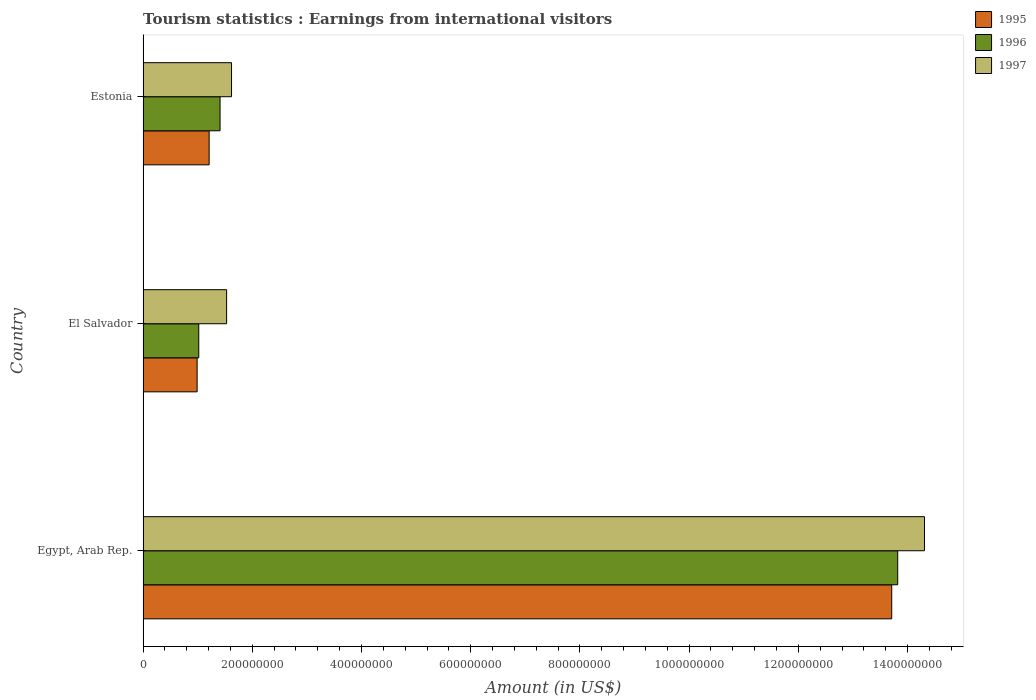How many groups of bars are there?
Ensure brevity in your answer.  3. Are the number of bars on each tick of the Y-axis equal?
Make the answer very short. Yes. What is the label of the 3rd group of bars from the top?
Keep it short and to the point. Egypt, Arab Rep. What is the earnings from international visitors in 1997 in El Salvador?
Offer a terse response. 1.53e+08. Across all countries, what is the maximum earnings from international visitors in 1995?
Your answer should be compact. 1.37e+09. Across all countries, what is the minimum earnings from international visitors in 1997?
Make the answer very short. 1.53e+08. In which country was the earnings from international visitors in 1997 maximum?
Offer a terse response. Egypt, Arab Rep. In which country was the earnings from international visitors in 1996 minimum?
Your response must be concise. El Salvador. What is the total earnings from international visitors in 1997 in the graph?
Make the answer very short. 1.75e+09. What is the difference between the earnings from international visitors in 1997 in Egypt, Arab Rep. and that in El Salvador?
Ensure brevity in your answer.  1.28e+09. What is the difference between the earnings from international visitors in 1996 in Estonia and the earnings from international visitors in 1995 in Egypt, Arab Rep.?
Provide a succinct answer. -1.23e+09. What is the average earnings from international visitors in 1997 per country?
Make the answer very short. 5.82e+08. What is the difference between the earnings from international visitors in 1997 and earnings from international visitors in 1996 in El Salvador?
Provide a short and direct response. 5.10e+07. In how many countries, is the earnings from international visitors in 1995 greater than 1360000000 US$?
Keep it short and to the point. 1. What is the ratio of the earnings from international visitors in 1996 in Egypt, Arab Rep. to that in El Salvador?
Give a very brief answer. 13.55. Is the earnings from international visitors in 1997 in Egypt, Arab Rep. less than that in El Salvador?
Keep it short and to the point. No. What is the difference between the highest and the second highest earnings from international visitors in 1995?
Offer a very short reply. 1.25e+09. What is the difference between the highest and the lowest earnings from international visitors in 1997?
Ensure brevity in your answer.  1.28e+09. In how many countries, is the earnings from international visitors in 1996 greater than the average earnings from international visitors in 1996 taken over all countries?
Keep it short and to the point. 1. What does the 1st bar from the top in Estonia represents?
Offer a terse response. 1997. How many bars are there?
Ensure brevity in your answer.  9. Are all the bars in the graph horizontal?
Ensure brevity in your answer.  Yes. Does the graph contain grids?
Your response must be concise. No. What is the title of the graph?
Provide a short and direct response. Tourism statistics : Earnings from international visitors. What is the label or title of the Y-axis?
Ensure brevity in your answer.  Country. What is the Amount (in US$) of 1995 in Egypt, Arab Rep.?
Your response must be concise. 1.37e+09. What is the Amount (in US$) of 1996 in Egypt, Arab Rep.?
Your response must be concise. 1.38e+09. What is the Amount (in US$) of 1997 in Egypt, Arab Rep.?
Offer a very short reply. 1.43e+09. What is the Amount (in US$) in 1995 in El Salvador?
Provide a short and direct response. 9.90e+07. What is the Amount (in US$) of 1996 in El Salvador?
Make the answer very short. 1.02e+08. What is the Amount (in US$) of 1997 in El Salvador?
Offer a terse response. 1.53e+08. What is the Amount (in US$) in 1995 in Estonia?
Provide a succinct answer. 1.21e+08. What is the Amount (in US$) in 1996 in Estonia?
Your answer should be compact. 1.41e+08. What is the Amount (in US$) of 1997 in Estonia?
Your answer should be very brief. 1.62e+08. Across all countries, what is the maximum Amount (in US$) in 1995?
Give a very brief answer. 1.37e+09. Across all countries, what is the maximum Amount (in US$) in 1996?
Provide a short and direct response. 1.38e+09. Across all countries, what is the maximum Amount (in US$) in 1997?
Ensure brevity in your answer.  1.43e+09. Across all countries, what is the minimum Amount (in US$) in 1995?
Your answer should be compact. 9.90e+07. Across all countries, what is the minimum Amount (in US$) of 1996?
Offer a terse response. 1.02e+08. Across all countries, what is the minimum Amount (in US$) of 1997?
Provide a short and direct response. 1.53e+08. What is the total Amount (in US$) in 1995 in the graph?
Your answer should be very brief. 1.59e+09. What is the total Amount (in US$) in 1996 in the graph?
Provide a succinct answer. 1.62e+09. What is the total Amount (in US$) in 1997 in the graph?
Your response must be concise. 1.75e+09. What is the difference between the Amount (in US$) of 1995 in Egypt, Arab Rep. and that in El Salvador?
Your answer should be very brief. 1.27e+09. What is the difference between the Amount (in US$) of 1996 in Egypt, Arab Rep. and that in El Salvador?
Provide a short and direct response. 1.28e+09. What is the difference between the Amount (in US$) of 1997 in Egypt, Arab Rep. and that in El Salvador?
Make the answer very short. 1.28e+09. What is the difference between the Amount (in US$) in 1995 in Egypt, Arab Rep. and that in Estonia?
Ensure brevity in your answer.  1.25e+09. What is the difference between the Amount (in US$) in 1996 in Egypt, Arab Rep. and that in Estonia?
Offer a very short reply. 1.24e+09. What is the difference between the Amount (in US$) of 1997 in Egypt, Arab Rep. and that in Estonia?
Make the answer very short. 1.27e+09. What is the difference between the Amount (in US$) of 1995 in El Salvador and that in Estonia?
Provide a succinct answer. -2.20e+07. What is the difference between the Amount (in US$) of 1996 in El Salvador and that in Estonia?
Provide a short and direct response. -3.90e+07. What is the difference between the Amount (in US$) of 1997 in El Salvador and that in Estonia?
Your response must be concise. -9.00e+06. What is the difference between the Amount (in US$) in 1995 in Egypt, Arab Rep. and the Amount (in US$) in 1996 in El Salvador?
Make the answer very short. 1.27e+09. What is the difference between the Amount (in US$) in 1995 in Egypt, Arab Rep. and the Amount (in US$) in 1997 in El Salvador?
Offer a terse response. 1.22e+09. What is the difference between the Amount (in US$) of 1996 in Egypt, Arab Rep. and the Amount (in US$) of 1997 in El Salvador?
Give a very brief answer. 1.23e+09. What is the difference between the Amount (in US$) in 1995 in Egypt, Arab Rep. and the Amount (in US$) in 1996 in Estonia?
Keep it short and to the point. 1.23e+09. What is the difference between the Amount (in US$) of 1995 in Egypt, Arab Rep. and the Amount (in US$) of 1997 in Estonia?
Your response must be concise. 1.21e+09. What is the difference between the Amount (in US$) of 1996 in Egypt, Arab Rep. and the Amount (in US$) of 1997 in Estonia?
Your answer should be very brief. 1.22e+09. What is the difference between the Amount (in US$) of 1995 in El Salvador and the Amount (in US$) of 1996 in Estonia?
Your answer should be compact. -4.20e+07. What is the difference between the Amount (in US$) of 1995 in El Salvador and the Amount (in US$) of 1997 in Estonia?
Offer a very short reply. -6.30e+07. What is the difference between the Amount (in US$) of 1996 in El Salvador and the Amount (in US$) of 1997 in Estonia?
Your response must be concise. -6.00e+07. What is the average Amount (in US$) of 1995 per country?
Your answer should be compact. 5.30e+08. What is the average Amount (in US$) in 1996 per country?
Offer a terse response. 5.42e+08. What is the average Amount (in US$) of 1997 per country?
Give a very brief answer. 5.82e+08. What is the difference between the Amount (in US$) in 1995 and Amount (in US$) in 1996 in Egypt, Arab Rep.?
Ensure brevity in your answer.  -1.10e+07. What is the difference between the Amount (in US$) of 1995 and Amount (in US$) of 1997 in Egypt, Arab Rep.?
Ensure brevity in your answer.  -6.00e+07. What is the difference between the Amount (in US$) in 1996 and Amount (in US$) in 1997 in Egypt, Arab Rep.?
Offer a very short reply. -4.90e+07. What is the difference between the Amount (in US$) of 1995 and Amount (in US$) of 1997 in El Salvador?
Give a very brief answer. -5.40e+07. What is the difference between the Amount (in US$) of 1996 and Amount (in US$) of 1997 in El Salvador?
Your response must be concise. -5.10e+07. What is the difference between the Amount (in US$) in 1995 and Amount (in US$) in 1996 in Estonia?
Give a very brief answer. -2.00e+07. What is the difference between the Amount (in US$) in 1995 and Amount (in US$) in 1997 in Estonia?
Your response must be concise. -4.10e+07. What is the difference between the Amount (in US$) in 1996 and Amount (in US$) in 1997 in Estonia?
Make the answer very short. -2.10e+07. What is the ratio of the Amount (in US$) in 1995 in Egypt, Arab Rep. to that in El Salvador?
Your response must be concise. 13.85. What is the ratio of the Amount (in US$) in 1996 in Egypt, Arab Rep. to that in El Salvador?
Offer a very short reply. 13.55. What is the ratio of the Amount (in US$) in 1997 in Egypt, Arab Rep. to that in El Salvador?
Provide a succinct answer. 9.35. What is the ratio of the Amount (in US$) of 1995 in Egypt, Arab Rep. to that in Estonia?
Offer a very short reply. 11.33. What is the ratio of the Amount (in US$) in 1996 in Egypt, Arab Rep. to that in Estonia?
Ensure brevity in your answer.  9.8. What is the ratio of the Amount (in US$) of 1997 in Egypt, Arab Rep. to that in Estonia?
Provide a short and direct response. 8.83. What is the ratio of the Amount (in US$) in 1995 in El Salvador to that in Estonia?
Your answer should be very brief. 0.82. What is the ratio of the Amount (in US$) of 1996 in El Salvador to that in Estonia?
Your answer should be very brief. 0.72. What is the ratio of the Amount (in US$) in 1997 in El Salvador to that in Estonia?
Your response must be concise. 0.94. What is the difference between the highest and the second highest Amount (in US$) of 1995?
Your answer should be compact. 1.25e+09. What is the difference between the highest and the second highest Amount (in US$) in 1996?
Keep it short and to the point. 1.24e+09. What is the difference between the highest and the second highest Amount (in US$) in 1997?
Provide a short and direct response. 1.27e+09. What is the difference between the highest and the lowest Amount (in US$) in 1995?
Your answer should be compact. 1.27e+09. What is the difference between the highest and the lowest Amount (in US$) of 1996?
Offer a very short reply. 1.28e+09. What is the difference between the highest and the lowest Amount (in US$) of 1997?
Keep it short and to the point. 1.28e+09. 